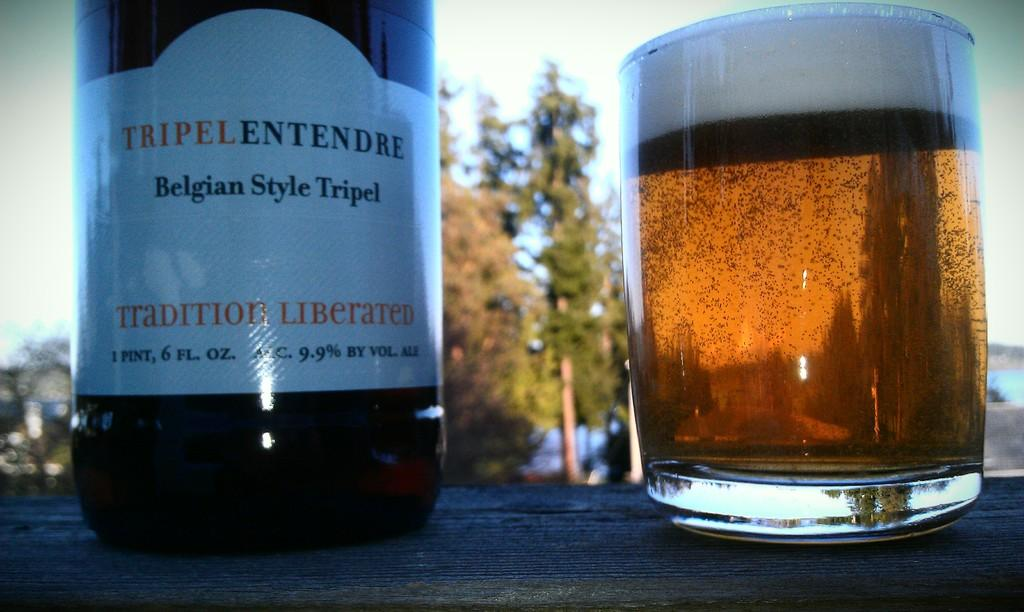<image>
Share a concise interpretation of the image provided. A bottle on table next to a mug of beer that says Tradition Liberated. 